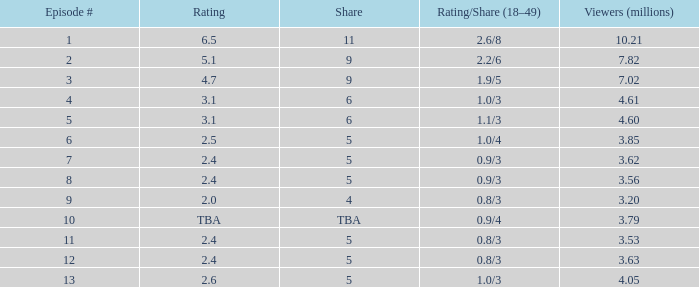What is the lowest number of million viewers for an episode before episode 5 with a rating/share of 1.1/3? None. 